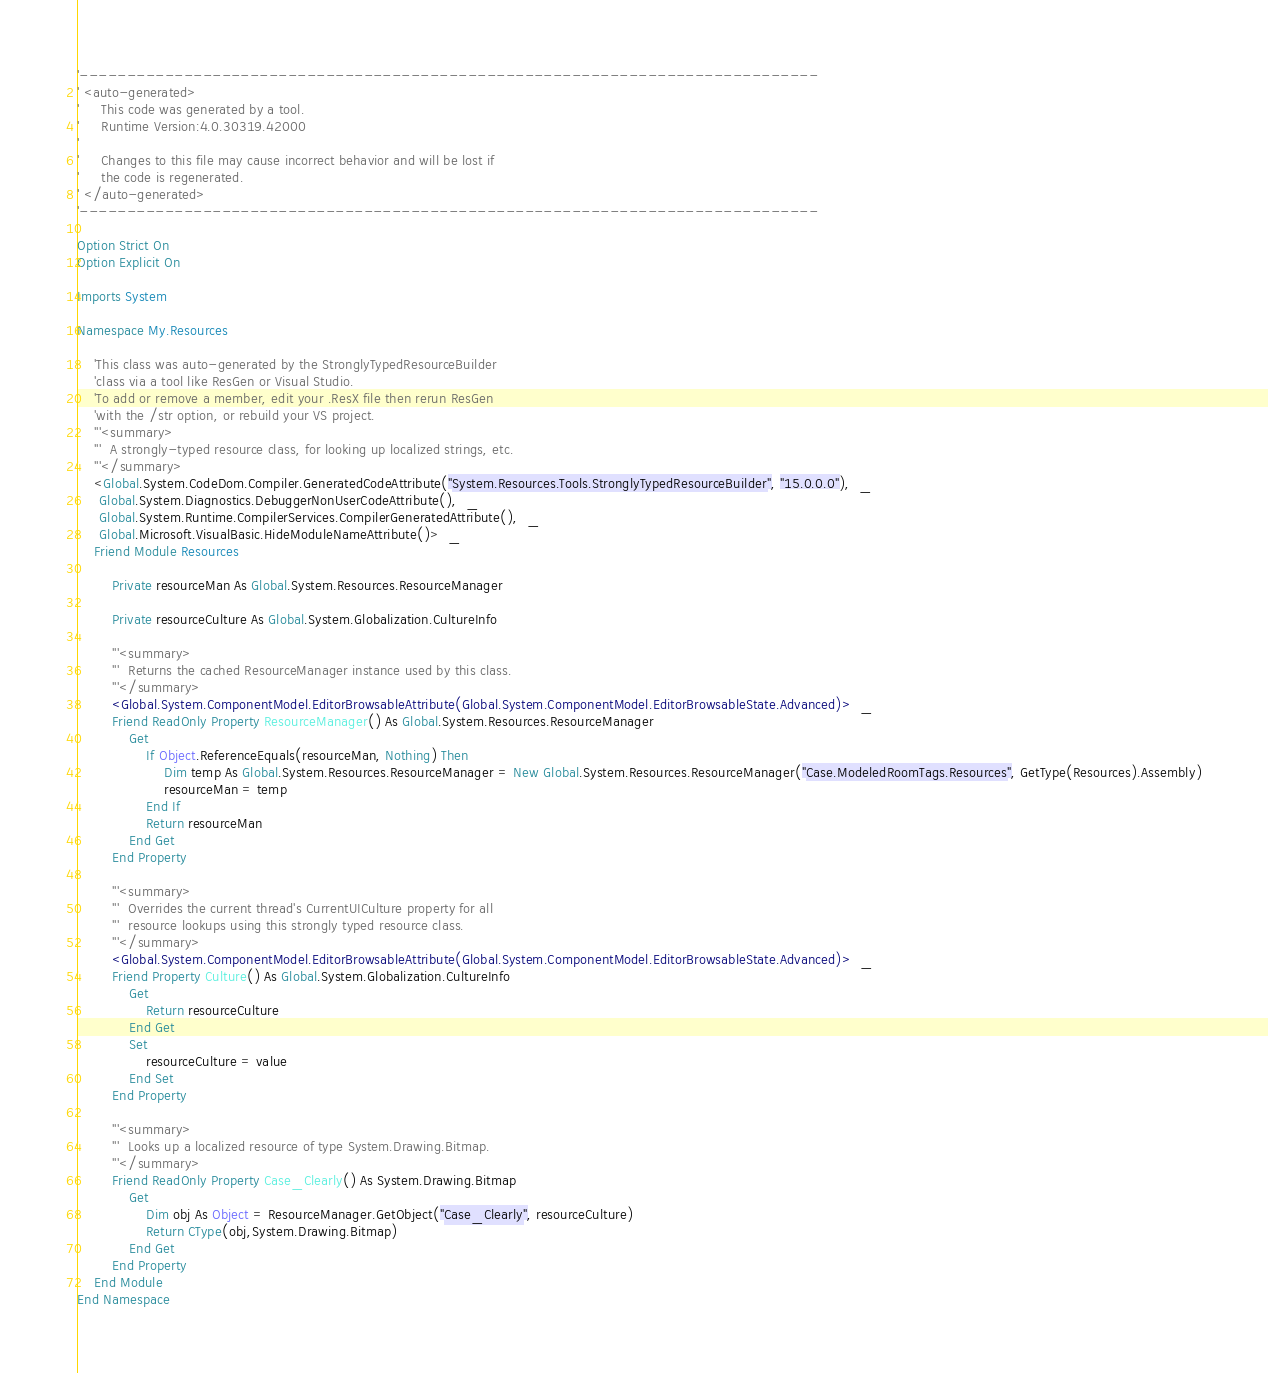<code> <loc_0><loc_0><loc_500><loc_500><_VisualBasic_>'------------------------------------------------------------------------------
' <auto-generated>
'     This code was generated by a tool.
'     Runtime Version:4.0.30319.42000
'
'     Changes to this file may cause incorrect behavior and will be lost if
'     the code is regenerated.
' </auto-generated>
'------------------------------------------------------------------------------

Option Strict On
Option Explicit On

Imports System

Namespace My.Resources
    
    'This class was auto-generated by the StronglyTypedResourceBuilder
    'class via a tool like ResGen or Visual Studio.
    'To add or remove a member, edit your .ResX file then rerun ResGen
    'with the /str option, or rebuild your VS project.
    '''<summary>
    '''  A strongly-typed resource class, for looking up localized strings, etc.
    '''</summary>
    <Global.System.CodeDom.Compiler.GeneratedCodeAttribute("System.Resources.Tools.StronglyTypedResourceBuilder", "15.0.0.0"),  _
     Global.System.Diagnostics.DebuggerNonUserCodeAttribute(),  _
     Global.System.Runtime.CompilerServices.CompilerGeneratedAttribute(),  _
     Global.Microsoft.VisualBasic.HideModuleNameAttribute()>  _
    Friend Module Resources
        
        Private resourceMan As Global.System.Resources.ResourceManager
        
        Private resourceCulture As Global.System.Globalization.CultureInfo
        
        '''<summary>
        '''  Returns the cached ResourceManager instance used by this class.
        '''</summary>
        <Global.System.ComponentModel.EditorBrowsableAttribute(Global.System.ComponentModel.EditorBrowsableState.Advanced)>  _
        Friend ReadOnly Property ResourceManager() As Global.System.Resources.ResourceManager
            Get
                If Object.ReferenceEquals(resourceMan, Nothing) Then
                    Dim temp As Global.System.Resources.ResourceManager = New Global.System.Resources.ResourceManager("Case.ModeledRoomTags.Resources", GetType(Resources).Assembly)
                    resourceMan = temp
                End If
                Return resourceMan
            End Get
        End Property
        
        '''<summary>
        '''  Overrides the current thread's CurrentUICulture property for all
        '''  resource lookups using this strongly typed resource class.
        '''</summary>
        <Global.System.ComponentModel.EditorBrowsableAttribute(Global.System.ComponentModel.EditorBrowsableState.Advanced)>  _
        Friend Property Culture() As Global.System.Globalization.CultureInfo
            Get
                Return resourceCulture
            End Get
            Set
                resourceCulture = value
            End Set
        End Property
        
        '''<summary>
        '''  Looks up a localized resource of type System.Drawing.Bitmap.
        '''</summary>
        Friend ReadOnly Property Case_Clearly() As System.Drawing.Bitmap
            Get
                Dim obj As Object = ResourceManager.GetObject("Case_Clearly", resourceCulture)
                Return CType(obj,System.Drawing.Bitmap)
            End Get
        End Property
    End Module
End Namespace
</code> 